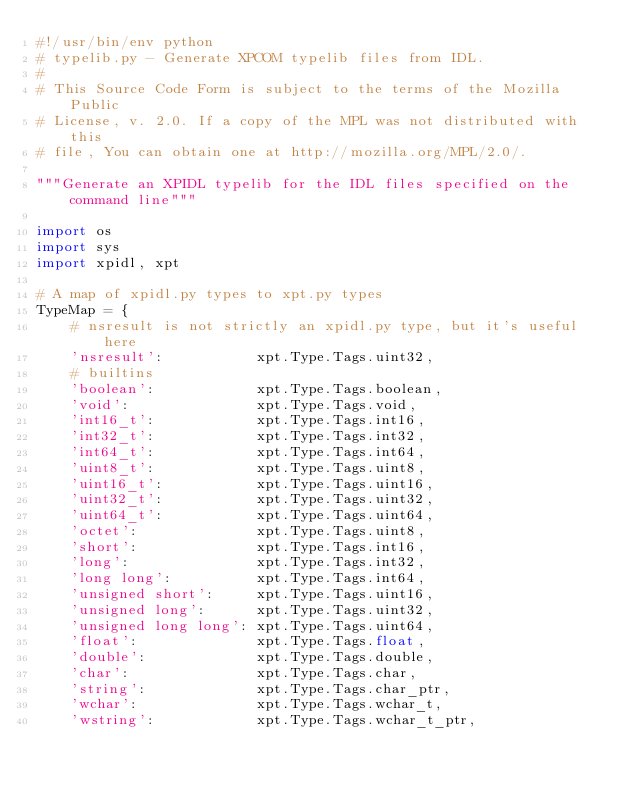Convert code to text. <code><loc_0><loc_0><loc_500><loc_500><_Python_>#!/usr/bin/env python
# typelib.py - Generate XPCOM typelib files from IDL.
#
# This Source Code Form is subject to the terms of the Mozilla Public
# License, v. 2.0. If a copy of the MPL was not distributed with this
# file, You can obtain one at http://mozilla.org/MPL/2.0/.

"""Generate an XPIDL typelib for the IDL files specified on the command line"""

import os
import sys
import xpidl, xpt

# A map of xpidl.py types to xpt.py types
TypeMap = {
    # nsresult is not strictly an xpidl.py type, but it's useful here
    'nsresult':           xpt.Type.Tags.uint32,
    # builtins
    'boolean':            xpt.Type.Tags.boolean,
    'void':               xpt.Type.Tags.void,
    'int16_t':            xpt.Type.Tags.int16,
    'int32_t':            xpt.Type.Tags.int32,
    'int64_t':            xpt.Type.Tags.int64,
    'uint8_t':            xpt.Type.Tags.uint8,
    'uint16_t':           xpt.Type.Tags.uint16,
    'uint32_t':           xpt.Type.Tags.uint32,
    'uint64_t':           xpt.Type.Tags.uint64,
    'octet':              xpt.Type.Tags.uint8,
    'short':              xpt.Type.Tags.int16,
    'long':               xpt.Type.Tags.int32,
    'long long':          xpt.Type.Tags.int64,
    'unsigned short':     xpt.Type.Tags.uint16,
    'unsigned long':      xpt.Type.Tags.uint32,
    'unsigned long long': xpt.Type.Tags.uint64,
    'float':              xpt.Type.Tags.float,
    'double':             xpt.Type.Tags.double,
    'char':               xpt.Type.Tags.char,
    'string':             xpt.Type.Tags.char_ptr,
    'wchar':              xpt.Type.Tags.wchar_t,
    'wstring':            xpt.Type.Tags.wchar_t_ptr,</code> 